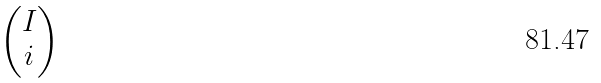<formula> <loc_0><loc_0><loc_500><loc_500>\begin{pmatrix} I \\ i \end{pmatrix}</formula> 